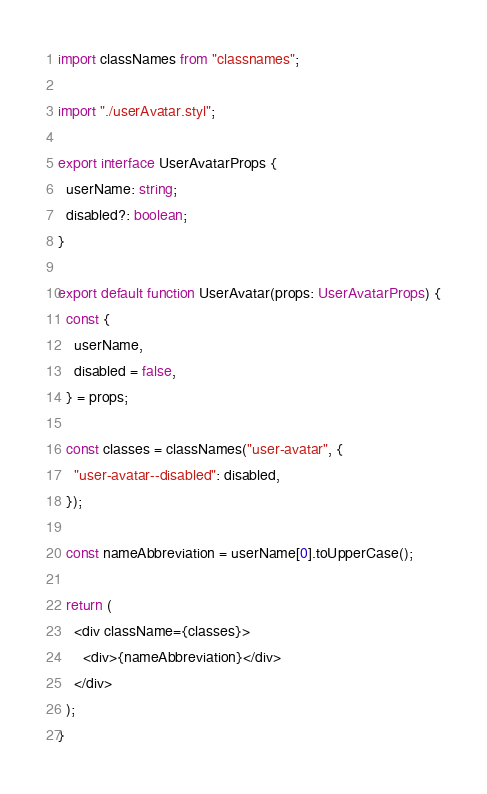<code> <loc_0><loc_0><loc_500><loc_500><_TypeScript_>import classNames from "classnames";

import "./userAvatar.styl";

export interface UserAvatarProps {
  userName: string;
  disabled?: boolean;
}

export default function UserAvatar(props: UserAvatarProps) {
  const {
    userName,
    disabled = false,
  } = props;

  const classes = classNames("user-avatar", {
    "user-avatar--disabled": disabled,
  });

  const nameAbbreviation = userName[0].toUpperCase();

  return (
    <div className={classes}>
      <div>{nameAbbreviation}</div>
    </div>
  );
}
</code> 